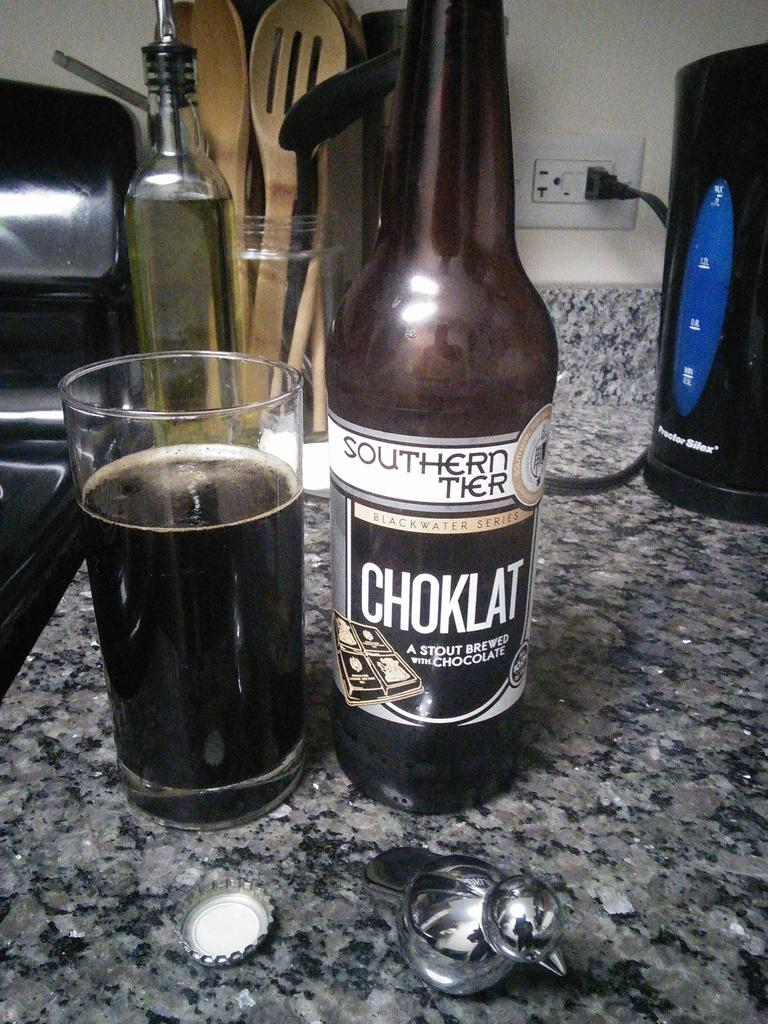<image>
Provide a brief description of the given image. A glass of chocolate flavored stout sits next to its bottle. 